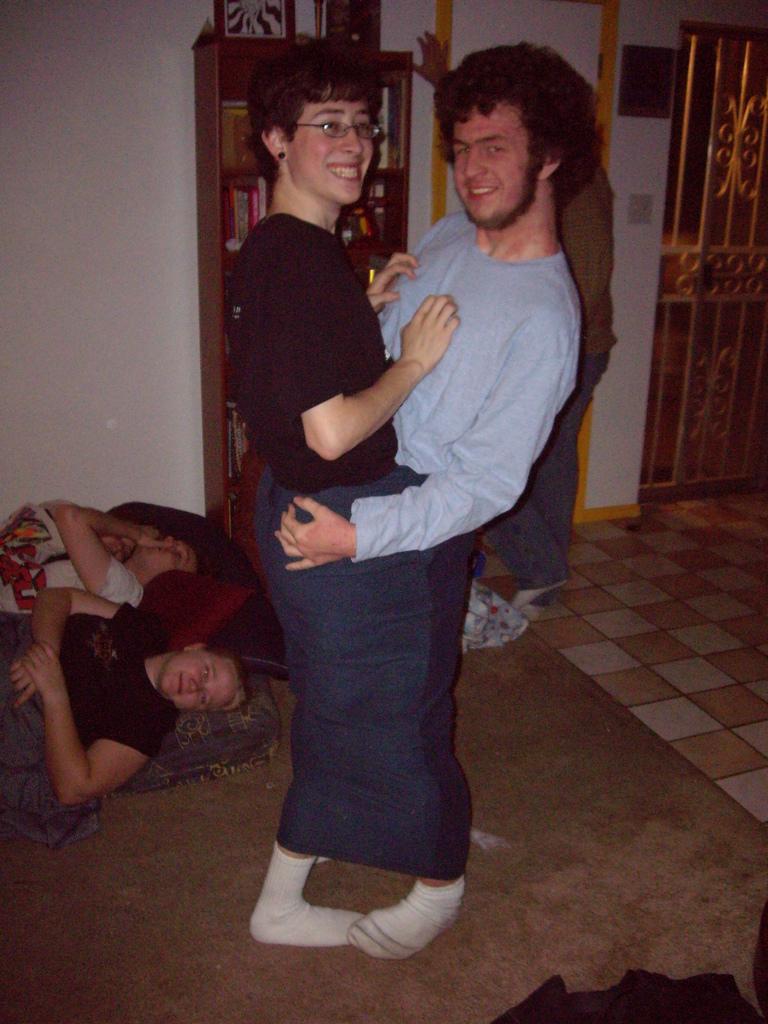Could you give a brief overview of what you see in this image? In this picture, we can see a few people, and among them two are highlighted, we can see the ground, wall with door, wooden shelf and some objects in it, we can see some objects in the bottom right corner. 